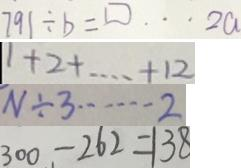<formula> <loc_0><loc_0><loc_500><loc_500>7 9 1 \div b = \square \cdots 2 a 
 1 + 2 + \cdots + 1 2 
 N \div 3 \cdots 2 
 3 0 0 - 2 6 2 = 1 3 8</formula> 